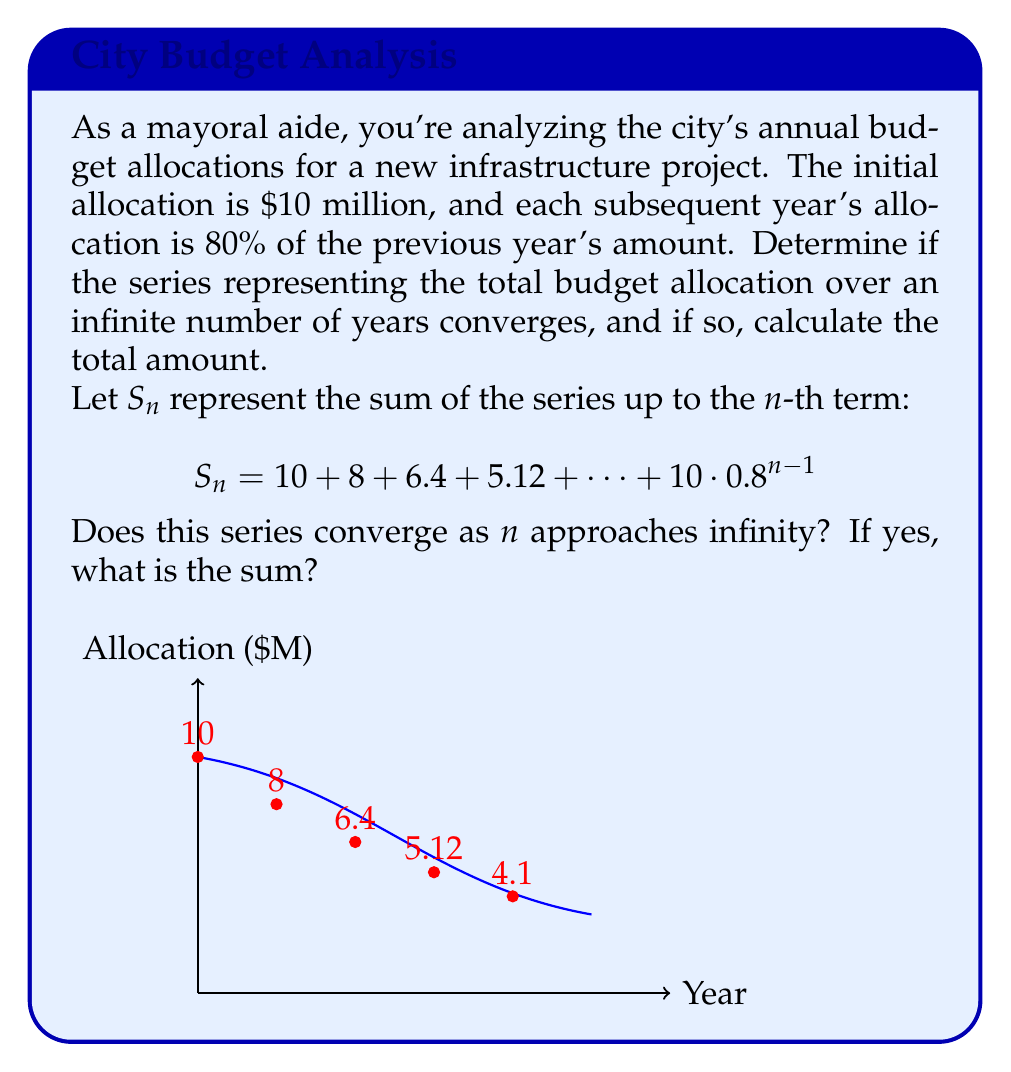Help me with this question. To analyze the convergence of this series, we can use the concept of geometric series.

1) First, identify the components of the geometric series:
   - First term, $a = 10$ (million dollars)
   - Common ratio, $r = 0.8$

2) The general form of a geometric series is:
   $$S_{\infty} = \frac{a}{1-r}, \text{ where } |r| < 1$$

3) Check if $|r| < 1$:
   $|0.8| = 0.8 < 1$, so this condition is satisfied.

4) Since $|r| < 1$, the series converges. We can now calculate the sum:

   $$S_{\infty} = \frac{a}{1-r} = \frac{10}{1-0.8} = \frac{10}{0.2} = 50$$

5) Therefore, the series converges to $50 million.

This means that over an infinite number of years, the total budget allocation for this project would approach, but never exceed, $50 million.
Answer: The series converges to $50 million. 